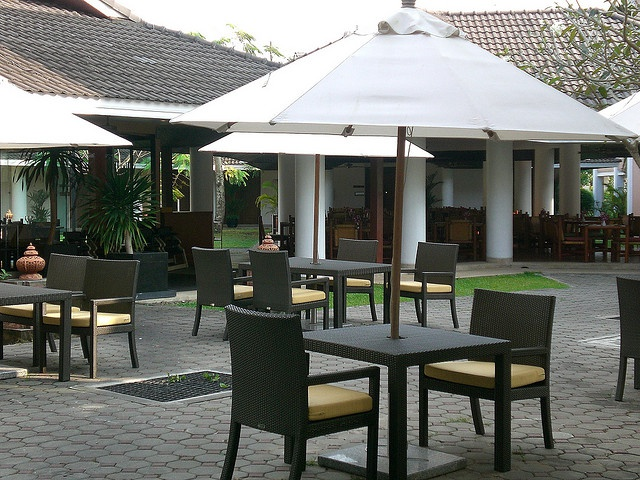Describe the objects in this image and their specific colors. I can see umbrella in lightgray, white, darkgray, and gray tones, chair in lightgray, black, darkgray, olive, and tan tones, dining table in lightgray, black, gray, and darkgray tones, chair in lightgray, black, gray, darkgray, and tan tones, and potted plant in lightgray, black, gray, and darkgreen tones in this image. 